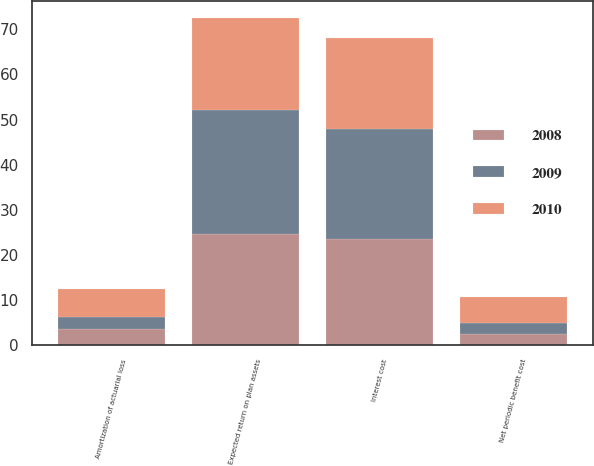Convert chart to OTSL. <chart><loc_0><loc_0><loc_500><loc_500><stacked_bar_chart><ecel><fcel>Interest cost<fcel>Expected return on plan assets<fcel>Amortization of actuarial loss<fcel>Net periodic benefit cost<nl><fcel>2010<fcel>20.1<fcel>20.4<fcel>6.2<fcel>5.9<nl><fcel>2008<fcel>23.6<fcel>24.7<fcel>3.6<fcel>2.5<nl><fcel>2009<fcel>24.4<fcel>27.5<fcel>2.7<fcel>2.4<nl></chart> 